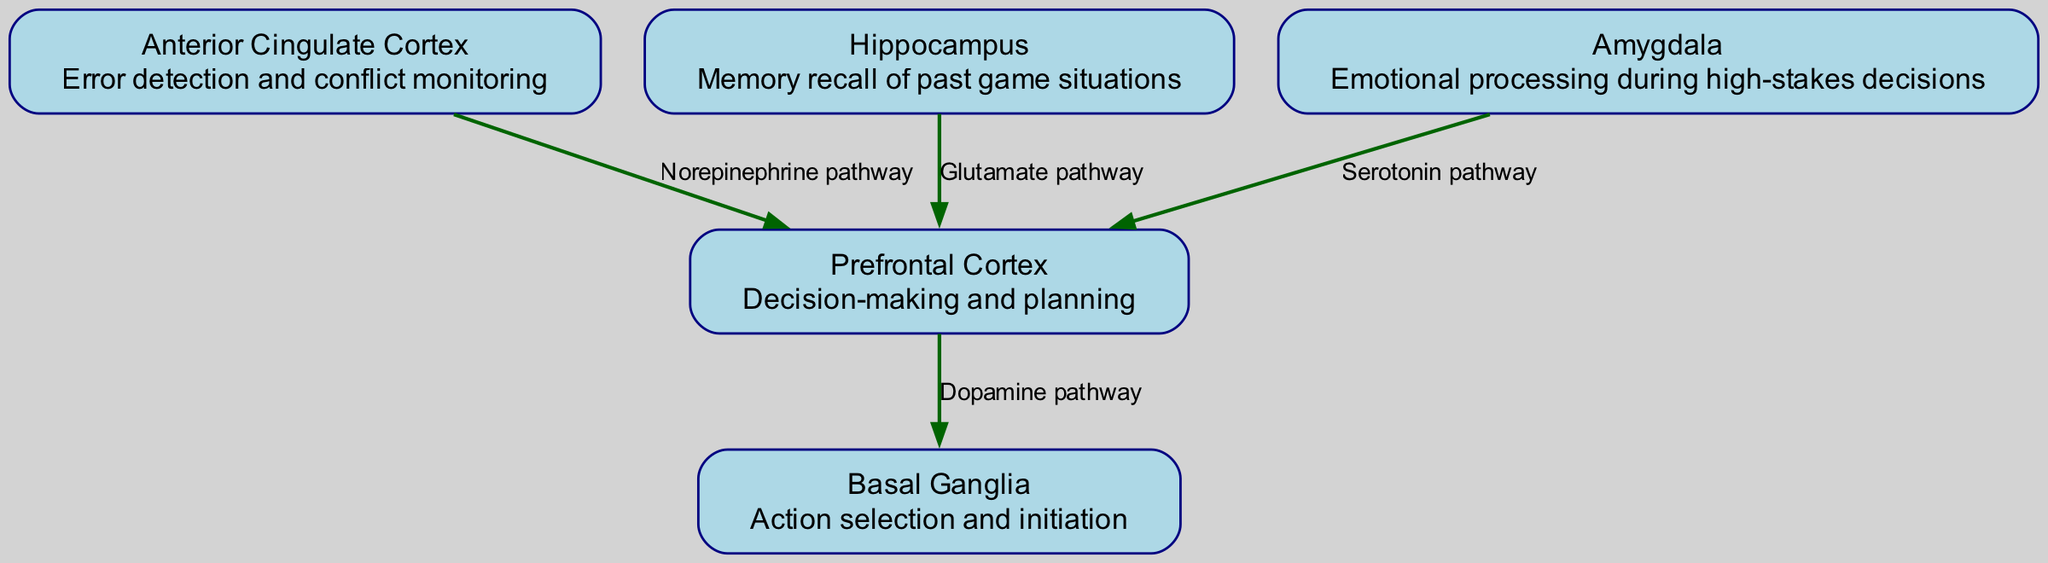What is the role of the prefrontal cortex? The prefrontal cortex is labeled as "Decision-making and planning," indicating that its primary function is related to making and planning decisions.
Answer: Decision-making and planning How many neurotransmitter pathways are shown in the diagram? The diagram includes four edges, each representing a different neurotransmitter pathway linking brain regions. Counting these edges gives the total number of pathways.
Answer: 4 Which brain region is responsible for error detection? The anterior cingulate cortex is described as responsible for "Error detection and conflict monitoring," confirming its specific role in identifying errors during decision-making.
Answer: Anterior Cingulate Cortex What neurotransmitter pathway connects the hippocampus to the prefrontal cortex? According to the diagram, the edge labeled "Glutamate pathway" indicates that the glutamate neurotransmitter pathway links the hippocampus to the prefrontal cortex.
Answer: Glutamate pathway How many brain regions are activated during strategic decision-making? The diagram lists five distinct brain regions, each specified as contributing to decision-making processes, hence confirming the total count of activated regions.
Answer: 5 Which brain region is associated with emotional processing? The amygdala is specifically identified as handling "Emotional processing during high-stakes decisions," which defines its role in the context of the diagram.
Answer: Amygdala What is the pathway from the anterior cingulate cortex to the prefrontal cortex? The relationship is indicated by an edge labeled "Norepinephrine pathway," demonstrating the neurotransmitter pathway that connects these two brain regions.
Answer: Norepinephrine pathway In which area is action selection and initiation accomplished? The basal ganglia is described as responsible for "Action selection and initiation," indicating its focused role in facilitating actions necessary for strategic decision-making.
Answer: Basal Ganglia What neurotransmitter pathway is involved in emotional processing during decision-making? The diagram indicates that the pathway from the amygdala to the prefrontal cortex is labeled as the "Serotonin pathway," which highlights its involvement in emotional processing.
Answer: Serotonin pathway 